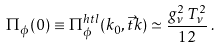Convert formula to latex. <formula><loc_0><loc_0><loc_500><loc_500>\Pi _ { \phi } ( 0 ) \equiv \Pi _ { \phi } ^ { h t l } ( k _ { 0 } , \vec { t } { k } ) \simeq \frac { g _ { \nu } ^ { 2 } \, T _ { \nu } ^ { 2 } } { 1 2 } \, .</formula> 